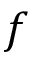Convert formula to latex. <formula><loc_0><loc_0><loc_500><loc_500>f</formula> 